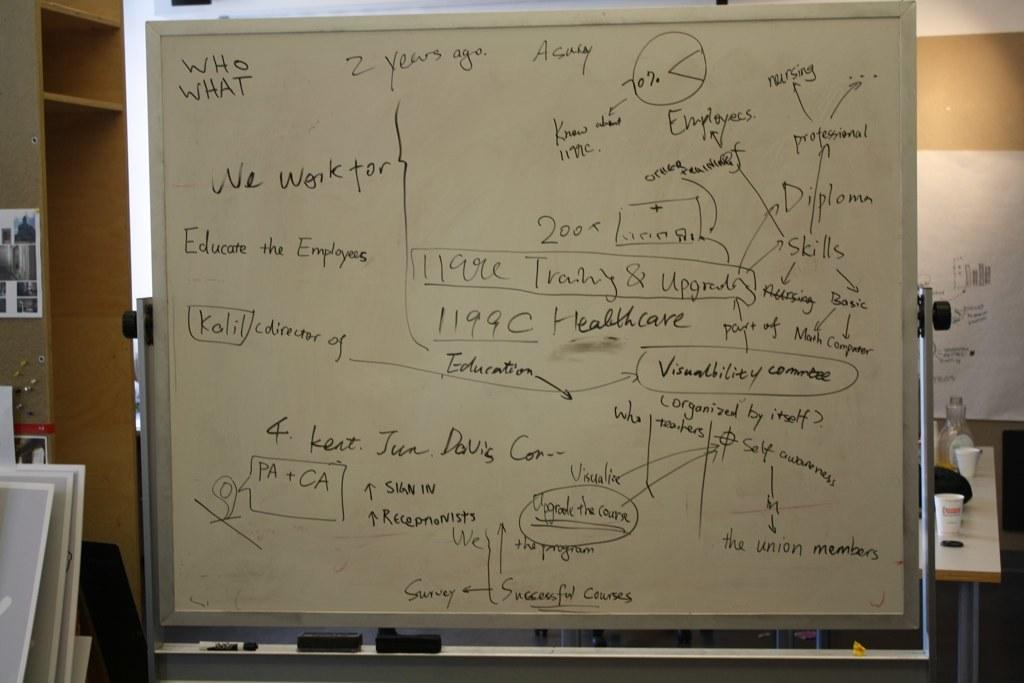<image>
Present a compact description of the photo's key features. A white board filled with notes including "Educate the Employees." 